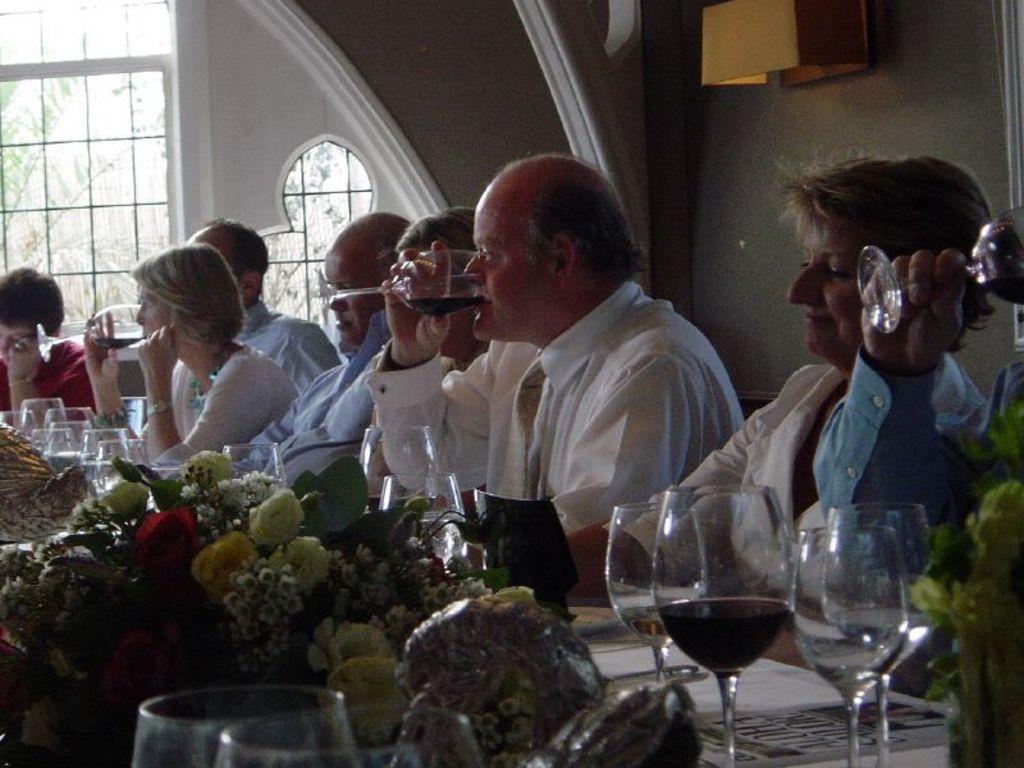Could you give a brief overview of what you see in this image? there are people sitting and having drinks there is a table in front of them on the table there are different items 